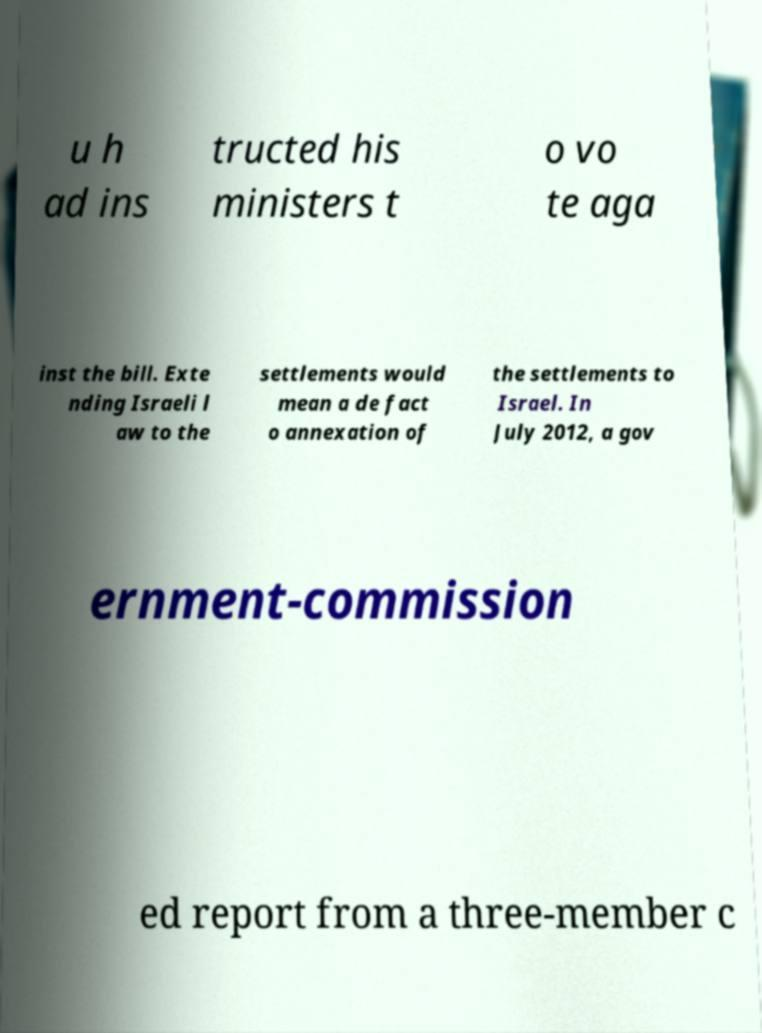Please identify and transcribe the text found in this image. u h ad ins tructed his ministers t o vo te aga inst the bill. Exte nding Israeli l aw to the settlements would mean a de fact o annexation of the settlements to Israel. In July 2012, a gov ernment-commission ed report from a three-member c 